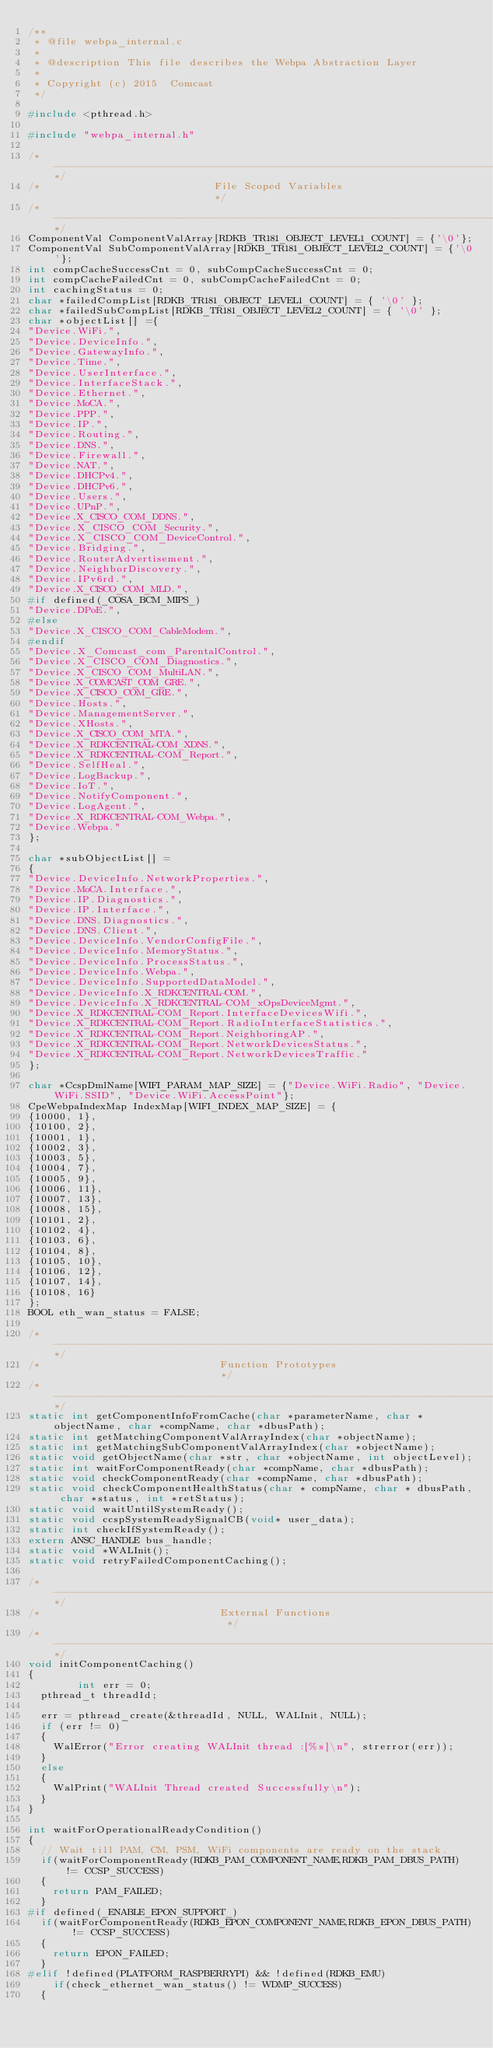Convert code to text. <code><loc_0><loc_0><loc_500><loc_500><_C_>/**
 * @file webpa_internal.c
 *
 * @description This file describes the Webpa Abstraction Layer
 *
 * Copyright (c) 2015  Comcast
 */

#include <pthread.h>

#include "webpa_internal.h"

/*----------------------------------------------------------------------------*/
/*                            File Scoped Variables                           */
/*----------------------------------------------------------------------------*/
ComponentVal ComponentValArray[RDKB_TR181_OBJECT_LEVEL1_COUNT] = {'\0'};
ComponentVal SubComponentValArray[RDKB_TR181_OBJECT_LEVEL2_COUNT] = {'\0'};
int compCacheSuccessCnt = 0, subCompCacheSuccessCnt = 0;
int compCacheFailedCnt = 0, subCompCacheFailedCnt = 0;
int cachingStatus = 0;
char *failedCompList[RDKB_TR181_OBJECT_LEVEL1_COUNT] = { '\0' };
char *failedSubCompList[RDKB_TR181_OBJECT_LEVEL2_COUNT] = { '\0' };
char *objectList[] ={
"Device.WiFi.",
"Device.DeviceInfo.",
"Device.GatewayInfo.",
"Device.Time.",
"Device.UserInterface.",
"Device.InterfaceStack.",
"Device.Ethernet.",
"Device.MoCA.",
"Device.PPP.",
"Device.IP.",
"Device.Routing.",
"Device.DNS.",
"Device.Firewall.",
"Device.NAT.",
"Device.DHCPv4.",
"Device.DHCPv6.",
"Device.Users.",
"Device.UPnP.",
"Device.X_CISCO_COM_DDNS.",
"Device.X_CISCO_COM_Security.",
"Device.X_CISCO_COM_DeviceControl.",
"Device.Bridging.",
"Device.RouterAdvertisement.",
"Device.NeighborDiscovery.",
"Device.IPv6rd.",
"Device.X_CISCO_COM_MLD.",
#if defined(_COSA_BCM_MIPS_)
"Device.DPoE.",
#else
"Device.X_CISCO_COM_CableModem.",
#endif
"Device.X_Comcast_com_ParentalControl.",
"Device.X_CISCO_COM_Diagnostics.",
"Device.X_CISCO_COM_MultiLAN.",
"Device.X_COMCAST_COM_GRE.",
"Device.X_CISCO_COM_GRE.",
"Device.Hosts.",
"Device.ManagementServer.",
"Device.XHosts.",
"Device.X_CISCO_COM_MTA.",
"Device.X_RDKCENTRAL-COM_XDNS.",
"Device.X_RDKCENTRAL-COM_Report.",
"Device.SelfHeal.",
"Device.LogBackup.",
"Device.IoT.",
"Device.NotifyComponent.",
"Device.LogAgent.",
"Device.X_RDKCENTRAL-COM_Webpa.",
"Device.Webpa."
};
 
char *subObjectList[] = 
{
"Device.DeviceInfo.NetworkProperties.",
"Device.MoCA.Interface.",
"Device.IP.Diagnostics.",
"Device.IP.Interface.",
"Device.DNS.Diagnostics.",
"Device.DNS.Client.",
"Device.DeviceInfo.VendorConfigFile.",
"Device.DeviceInfo.MemoryStatus.",
"Device.DeviceInfo.ProcessStatus.",
"Device.DeviceInfo.Webpa.",
"Device.DeviceInfo.SupportedDataModel.",
"Device.DeviceInfo.X_RDKCENTRAL-COM.",
"Device.DeviceInfo.X_RDKCENTRAL-COM_xOpsDeviceMgmt.",
"Device.X_RDKCENTRAL-COM_Report.InterfaceDevicesWifi.",
"Device.X_RDKCENTRAL-COM_Report.RadioInterfaceStatistics.",
"Device.X_RDKCENTRAL-COM_Report.NeighboringAP.",
"Device.X_RDKCENTRAL-COM_Report.NetworkDevicesStatus.",
"Device.X_RDKCENTRAL-COM_Report.NetworkDevicesTraffic."
}; 

char *CcspDmlName[WIFI_PARAM_MAP_SIZE] = {"Device.WiFi.Radio", "Device.WiFi.SSID", "Device.WiFi.AccessPoint"};
CpeWebpaIndexMap IndexMap[WIFI_INDEX_MAP_SIZE] = {
{10000, 1},
{10100, 2},
{10001, 1},
{10002, 3},
{10003, 5},
{10004, 7},
{10005, 9},
{10006, 11},
{10007, 13},
{10008, 15},
{10101, 2},
{10102, 4},
{10103, 6},
{10104, 8},
{10105, 10},
{10106, 12},
{10107, 14},
{10108, 16}
};
BOOL eth_wan_status = FALSE;

/*----------------------------------------------------------------------------*/
/*                             Function Prototypes                            */
/*----------------------------------------------------------------------------*/
static int getComponentInfoFromCache(char *parameterName, char *objectName, char *compName, char *dbusPath);
static int getMatchingComponentValArrayIndex(char *objectName);
static int getMatchingSubComponentValArrayIndex(char *objectName);
static void getObjectName(char *str, char *objectName, int objectLevel);
static int waitForComponentReady(char *compName, char *dbusPath);
static void checkComponentReady(char *compName, char *dbusPath);
static void checkComponentHealthStatus(char * compName, char * dbusPath, char *status, int *retStatus);
static void waitUntilSystemReady();
static void ccspSystemReadySignalCB(void* user_data);
static int checkIfSystemReady();
extern ANSC_HANDLE bus_handle;
static void *WALInit();
static void retryFailedComponentCaching();

/*----------------------------------------------------------------------------*/
/*                             External Functions                             */
/*----------------------------------------------------------------------------*/
void initComponentCaching()
{
        int err = 0;
	pthread_t threadId;

	err = pthread_create(&threadId, NULL, WALInit, NULL);
	if (err != 0)
	{
		WalError("Error creating WALInit thread :[%s]\n", strerror(err));
	}
	else
	{
		WalPrint("WALInit Thread created Successfully\n");
	}
}

int waitForOperationalReadyCondition()
{
	// Wait till PAM, CM, PSM, WiFi components are ready on the stack.
	if(waitForComponentReady(RDKB_PAM_COMPONENT_NAME,RDKB_PAM_DBUS_PATH) != CCSP_SUCCESS)
	{
		return PAM_FAILED;
	}
#if defined(_ENABLE_EPON_SUPPORT_)
	if(waitForComponentReady(RDKB_EPON_COMPONENT_NAME,RDKB_EPON_DBUS_PATH) != CCSP_SUCCESS)
	{
		return EPON_FAILED;
	}
#elif !defined(PLATFORM_RASPBERRYPI) && !defined(RDKB_EMU)
    if(check_ethernet_wan_status() != WDMP_SUCCESS)
	{</code> 